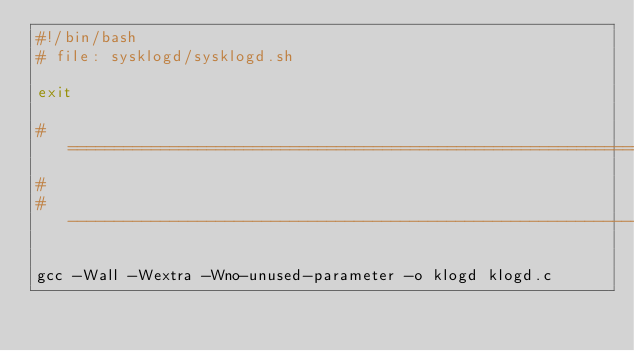<code> <loc_0><loc_0><loc_500><loc_500><_Bash_>#!/bin/bash
# file: sysklogd/sysklogd.sh

exit

# ====================================================================
#
# --------------------------------------------------------------------

gcc -Wall -Wextra -Wno-unused-parameter -o klogd klogd.c</code> 